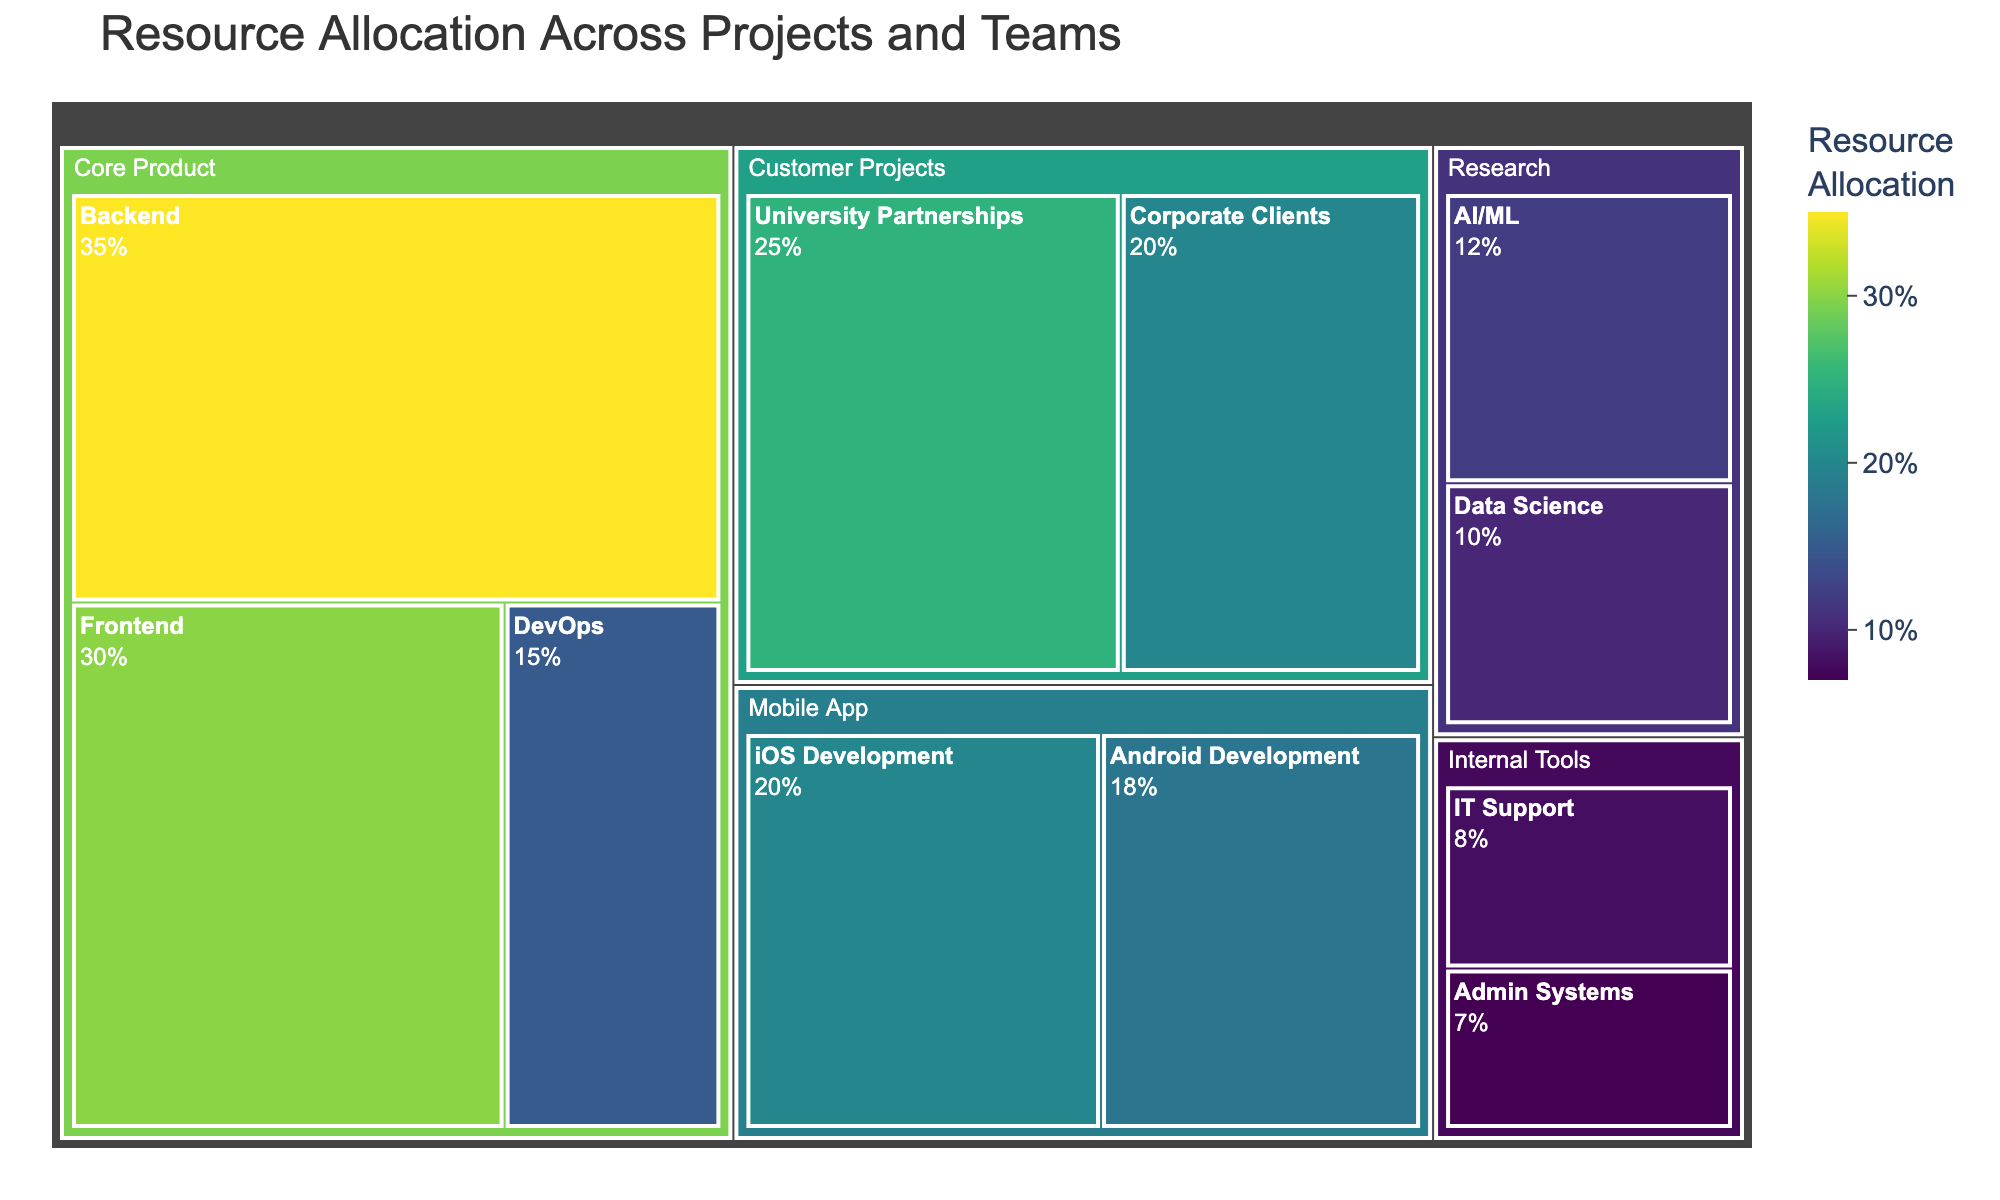What's the title of the Treemap? The title of the Treemap is clearly displayed at the top of the chart.
Answer: Resource Allocation Across Projects and Teams Which team has the highest resource allocation? By examining the area size and the percentage label, "Backend" in the "Core Product" project shows the highest value with 35%.
Answer: Backend How many projects are displayed in the Treemap? The number of different unique project names at the higher hierarchical level can be counted.
Answer: 5 What percentage of resources is allocated to the "Mobile App" project? The "iOS Development" and "Android Development" teams belong to "Mobile App." Adding their resources gives 20% + 18% = 38%.
Answer: 38% Which project has the smallest total resource allocation and what is its value? Summing up the values for each project, "Internal Tools" has 8% + 7% = 15%, which is the smallest.
Answer: Internal Tools, 15% Is more resource allocated to "iOS Development" or "University Partnerships"? Comparing the percentages, "iOS Development" has 20%, while "University Partnerships" has 25%.
Answer: University Partnerships What is the combined resource allocation for the "Research" project? Adding the resources for "AI/ML" and "Data Science" yields 12% + 10% = 22%.
Answer: 22% Compare the resource allocation between "Frontend" and "IT Support". Which one has more, and by how much? "Frontend" has 30%, while "IT Support" has 8%. 30% - 8% = 22%.
Answer: Frontend, 22% What is the resource allocation for the team with the least resources in the "Customer Projects" project? The "Customer Projects" project includes "University Partnerships" (25%) and "Corporate Clients" (20%). The lesser value is 20%.
Answer: Corporate Clients, 20% How do the resource allocations of "Core Product" and "Customer Projects" compare? Summing up "Core Product" teams (30% + 35% + 15%) gives 80%, and "Customer Projects" (25% + 20%) gives 45%. So 80% - 45% = 35%.
Answer: Core Product has 35% more 